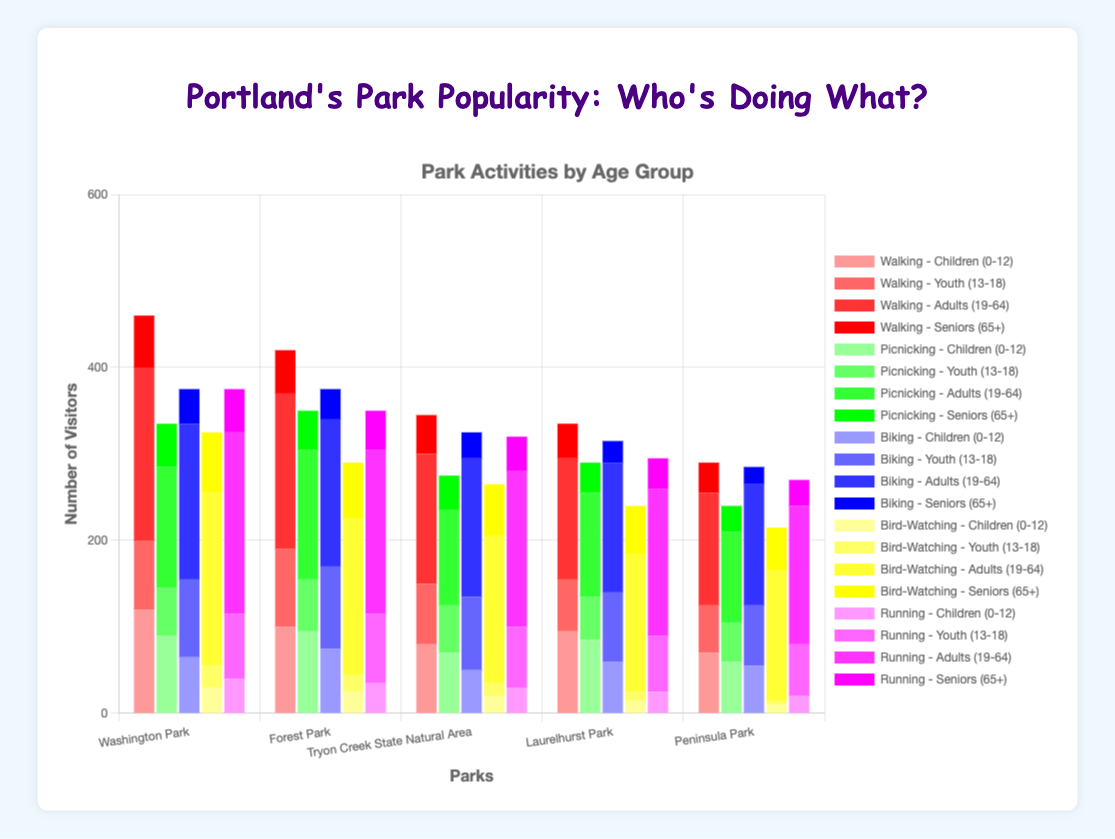Which park has the most visitors for running? Look at the stack of bars for each park under the "Running" category and find the tallest bar. The tallest bar among all parks represents the park with the most visitors for running.
Answer: Washington Park How many children aged 0-12 are walking in Tryon Creek State Natural Area? Refer to the bar section labeled "Walking" for Tryon Creek State Natural Area and find the height corresponding to "Children (0-12)".
Answer: 80 Which age group has the highest bird-watching activity in Peninsula Park? Look at the different colored segments in the "Bird-Watching" stack for Peninsula Park and identify the tallest segment.
Answer: Adults (19-64) Compare the number of adults (19-64) and seniors (65+) running in Laurelhurst Park. Who has more, and by how much? Find the bar segments for "Adults (19-64)" and "Seniors (65+)" under the "Running" category for Laurelhurst Park. Calculate the difference by subtracting the senior segment value from the adult segment value.
Answer: Adults by 140 Which activity has the least variation in the number of youth (13-18) participants across all parks? Calculate the variation for youth (13-18) in each activity by finding the range (maximum value - minimum value) and comparing these ranges.
Answer: Picnicking How many total seniors (65+) are bird-watching in all parks combined? Sum the "Seniors (65+)" bar segments under the "Bird-Watching" category for all parks.
Answer: 300 Which park has the least number of visitors for picnicking across all age groups? Sum up the number of visitors for each age group under the "Picnicking" category for each park and find the park with the smallest total.
Answer: Peninsula Park How many more youth (13-18) are biking compared to walking in Forest Park? Find the values for youth (13-18) under "Biking" and "Walking" in Forest Park, then subtract the walking value from the biking value.
Answer: 5 What's the average number of adults (19-64) walking across all parks? Sum the number of adults (19-64) walking in all parks and divide by the number of parks.
Answer: 160 In which park do children (0-12) prefer picnicking over walking? Compare the number of children (0-12) under "Picnicking" and "Walking" for each park and identify any parks where picnicking numbers are higher than walking.
Answer: Laurelhurst Park, Tryon Creek State Natural Area 